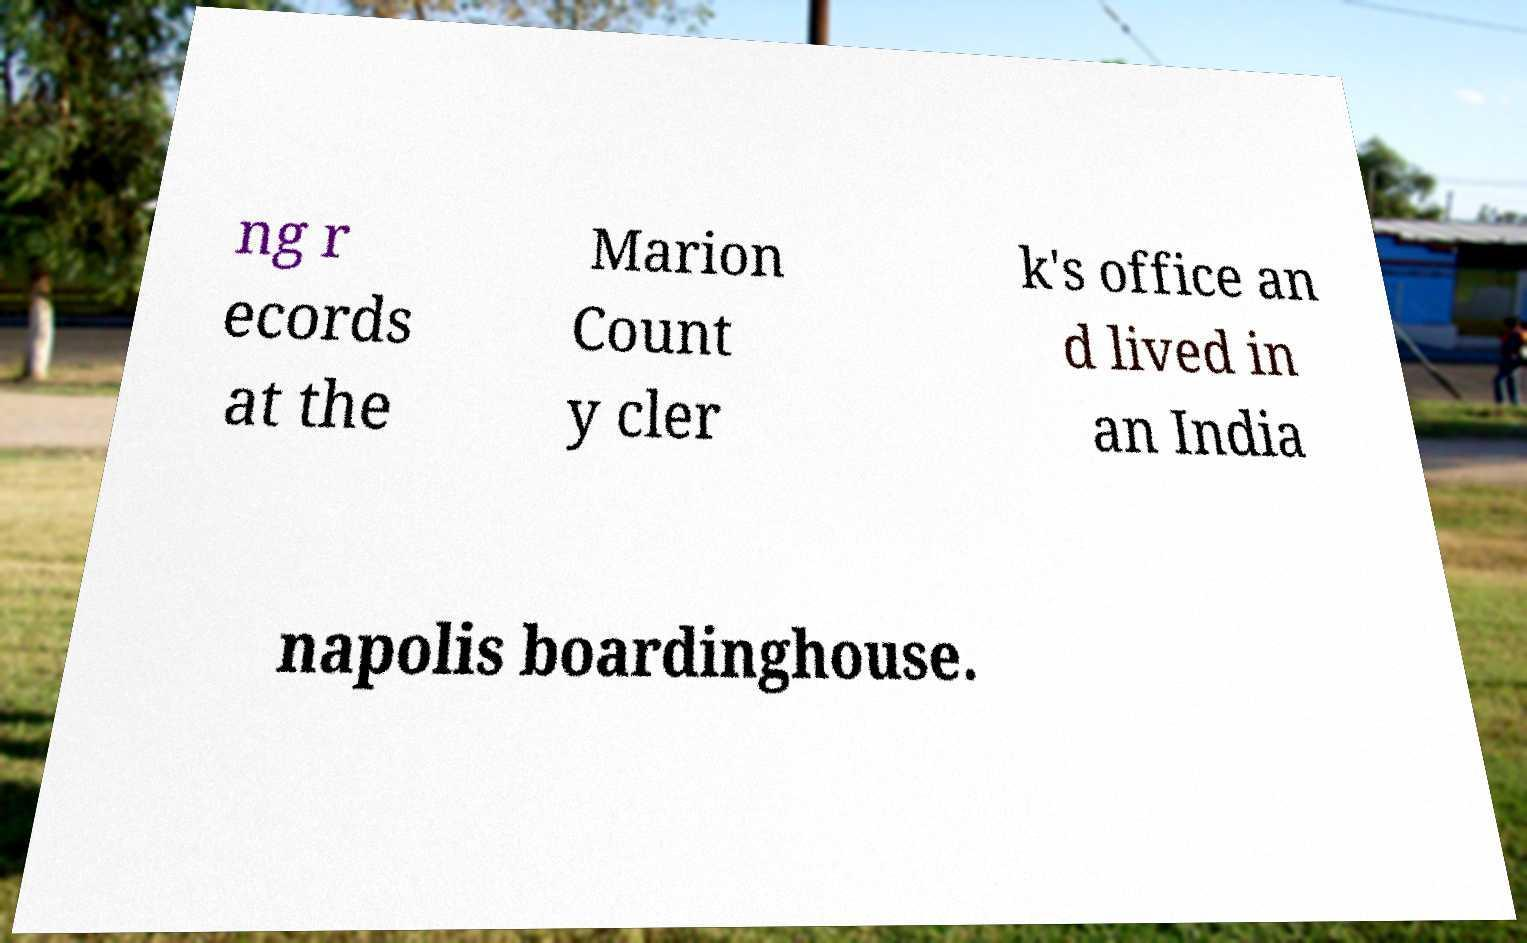Please read and relay the text visible in this image. What does it say? ng r ecords at the Marion Count y cler k's office an d lived in an India napolis boardinghouse. 